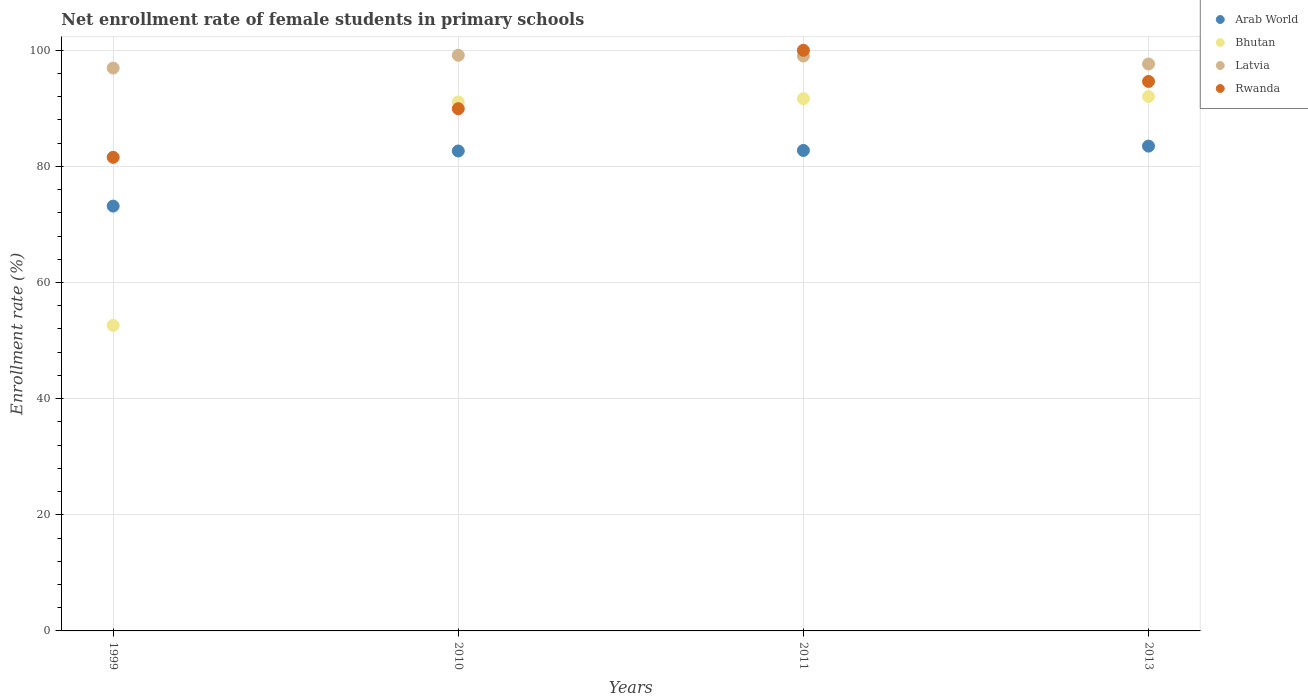What is the net enrollment rate of female students in primary schools in Latvia in 1999?
Your answer should be compact. 96.93. Across all years, what is the maximum net enrollment rate of female students in primary schools in Arab World?
Provide a succinct answer. 83.49. Across all years, what is the minimum net enrollment rate of female students in primary schools in Bhutan?
Provide a succinct answer. 52.61. In which year was the net enrollment rate of female students in primary schools in Latvia maximum?
Your answer should be very brief. 2010. In which year was the net enrollment rate of female students in primary schools in Arab World minimum?
Your response must be concise. 1999. What is the total net enrollment rate of female students in primary schools in Bhutan in the graph?
Offer a terse response. 327.39. What is the difference between the net enrollment rate of female students in primary schools in Bhutan in 1999 and that in 2011?
Give a very brief answer. -39.05. What is the difference between the net enrollment rate of female students in primary schools in Rwanda in 2013 and the net enrollment rate of female students in primary schools in Bhutan in 1999?
Offer a very short reply. 42.01. What is the average net enrollment rate of female students in primary schools in Latvia per year?
Your answer should be very brief. 98.17. In the year 2013, what is the difference between the net enrollment rate of female students in primary schools in Bhutan and net enrollment rate of female students in primary schools in Latvia?
Provide a succinct answer. -5.59. In how many years, is the net enrollment rate of female students in primary schools in Arab World greater than 72 %?
Make the answer very short. 4. What is the ratio of the net enrollment rate of female students in primary schools in Latvia in 2011 to that in 2013?
Provide a short and direct response. 1.01. Is the difference between the net enrollment rate of female students in primary schools in Bhutan in 2010 and 2013 greater than the difference between the net enrollment rate of female students in primary schools in Latvia in 2010 and 2013?
Your answer should be very brief. No. What is the difference between the highest and the second highest net enrollment rate of female students in primary schools in Latvia?
Keep it short and to the point. 0.13. What is the difference between the highest and the lowest net enrollment rate of female students in primary schools in Bhutan?
Your response must be concise. 39.42. Is the sum of the net enrollment rate of female students in primary schools in Arab World in 2010 and 2013 greater than the maximum net enrollment rate of female students in primary schools in Bhutan across all years?
Give a very brief answer. Yes. Is it the case that in every year, the sum of the net enrollment rate of female students in primary schools in Bhutan and net enrollment rate of female students in primary schools in Arab World  is greater than the sum of net enrollment rate of female students in primary schools in Rwanda and net enrollment rate of female students in primary schools in Latvia?
Offer a terse response. No. Does the net enrollment rate of female students in primary schools in Rwanda monotonically increase over the years?
Ensure brevity in your answer.  No. Is the net enrollment rate of female students in primary schools in Latvia strictly greater than the net enrollment rate of female students in primary schools in Bhutan over the years?
Your answer should be very brief. Yes. How many years are there in the graph?
Keep it short and to the point. 4. Are the values on the major ticks of Y-axis written in scientific E-notation?
Keep it short and to the point. No. Does the graph contain grids?
Give a very brief answer. Yes. Where does the legend appear in the graph?
Offer a terse response. Top right. How many legend labels are there?
Provide a short and direct response. 4. What is the title of the graph?
Offer a very short reply. Net enrollment rate of female students in primary schools. Does "Chile" appear as one of the legend labels in the graph?
Provide a short and direct response. No. What is the label or title of the X-axis?
Your answer should be very brief. Years. What is the label or title of the Y-axis?
Offer a terse response. Enrollment rate (%). What is the Enrollment rate (%) in Arab World in 1999?
Provide a succinct answer. 73.16. What is the Enrollment rate (%) of Bhutan in 1999?
Make the answer very short. 52.61. What is the Enrollment rate (%) in Latvia in 1999?
Offer a very short reply. 96.93. What is the Enrollment rate (%) in Rwanda in 1999?
Provide a short and direct response. 81.56. What is the Enrollment rate (%) in Arab World in 2010?
Give a very brief answer. 82.65. What is the Enrollment rate (%) in Bhutan in 2010?
Keep it short and to the point. 91.09. What is the Enrollment rate (%) in Latvia in 2010?
Give a very brief answer. 99.13. What is the Enrollment rate (%) in Rwanda in 2010?
Ensure brevity in your answer.  89.93. What is the Enrollment rate (%) in Arab World in 2011?
Give a very brief answer. 82.74. What is the Enrollment rate (%) of Bhutan in 2011?
Give a very brief answer. 91.66. What is the Enrollment rate (%) in Latvia in 2011?
Your response must be concise. 99. What is the Enrollment rate (%) in Rwanda in 2011?
Give a very brief answer. 99.98. What is the Enrollment rate (%) in Arab World in 2013?
Your answer should be compact. 83.49. What is the Enrollment rate (%) of Bhutan in 2013?
Provide a short and direct response. 92.03. What is the Enrollment rate (%) of Latvia in 2013?
Provide a short and direct response. 97.63. What is the Enrollment rate (%) in Rwanda in 2013?
Your response must be concise. 94.62. Across all years, what is the maximum Enrollment rate (%) of Arab World?
Ensure brevity in your answer.  83.49. Across all years, what is the maximum Enrollment rate (%) of Bhutan?
Provide a short and direct response. 92.03. Across all years, what is the maximum Enrollment rate (%) in Latvia?
Your answer should be very brief. 99.13. Across all years, what is the maximum Enrollment rate (%) in Rwanda?
Provide a succinct answer. 99.98. Across all years, what is the minimum Enrollment rate (%) of Arab World?
Keep it short and to the point. 73.16. Across all years, what is the minimum Enrollment rate (%) in Bhutan?
Make the answer very short. 52.61. Across all years, what is the minimum Enrollment rate (%) of Latvia?
Make the answer very short. 96.93. Across all years, what is the minimum Enrollment rate (%) in Rwanda?
Your answer should be compact. 81.56. What is the total Enrollment rate (%) in Arab World in the graph?
Offer a terse response. 322.03. What is the total Enrollment rate (%) in Bhutan in the graph?
Ensure brevity in your answer.  327.39. What is the total Enrollment rate (%) in Latvia in the graph?
Provide a short and direct response. 392.68. What is the total Enrollment rate (%) of Rwanda in the graph?
Keep it short and to the point. 366.09. What is the difference between the Enrollment rate (%) of Arab World in 1999 and that in 2010?
Your answer should be very brief. -9.49. What is the difference between the Enrollment rate (%) in Bhutan in 1999 and that in 2010?
Give a very brief answer. -38.47. What is the difference between the Enrollment rate (%) in Latvia in 1999 and that in 2010?
Make the answer very short. -2.2. What is the difference between the Enrollment rate (%) in Rwanda in 1999 and that in 2010?
Your answer should be compact. -8.37. What is the difference between the Enrollment rate (%) in Arab World in 1999 and that in 2011?
Offer a terse response. -9.58. What is the difference between the Enrollment rate (%) in Bhutan in 1999 and that in 2011?
Keep it short and to the point. -39.05. What is the difference between the Enrollment rate (%) of Latvia in 1999 and that in 2011?
Ensure brevity in your answer.  -2.07. What is the difference between the Enrollment rate (%) of Rwanda in 1999 and that in 2011?
Your answer should be very brief. -18.42. What is the difference between the Enrollment rate (%) in Arab World in 1999 and that in 2013?
Provide a short and direct response. -10.33. What is the difference between the Enrollment rate (%) in Bhutan in 1999 and that in 2013?
Keep it short and to the point. -39.42. What is the difference between the Enrollment rate (%) in Latvia in 1999 and that in 2013?
Keep it short and to the point. -0.7. What is the difference between the Enrollment rate (%) of Rwanda in 1999 and that in 2013?
Offer a very short reply. -13.07. What is the difference between the Enrollment rate (%) in Arab World in 2010 and that in 2011?
Make the answer very short. -0.09. What is the difference between the Enrollment rate (%) in Bhutan in 2010 and that in 2011?
Provide a short and direct response. -0.58. What is the difference between the Enrollment rate (%) in Latvia in 2010 and that in 2011?
Keep it short and to the point. 0.13. What is the difference between the Enrollment rate (%) of Rwanda in 2010 and that in 2011?
Ensure brevity in your answer.  -10.05. What is the difference between the Enrollment rate (%) of Arab World in 2010 and that in 2013?
Provide a short and direct response. -0.84. What is the difference between the Enrollment rate (%) of Bhutan in 2010 and that in 2013?
Give a very brief answer. -0.95. What is the difference between the Enrollment rate (%) in Latvia in 2010 and that in 2013?
Keep it short and to the point. 1.5. What is the difference between the Enrollment rate (%) in Rwanda in 2010 and that in 2013?
Give a very brief answer. -4.69. What is the difference between the Enrollment rate (%) in Arab World in 2011 and that in 2013?
Your answer should be very brief. -0.75. What is the difference between the Enrollment rate (%) in Bhutan in 2011 and that in 2013?
Offer a terse response. -0.37. What is the difference between the Enrollment rate (%) of Latvia in 2011 and that in 2013?
Provide a short and direct response. 1.37. What is the difference between the Enrollment rate (%) of Rwanda in 2011 and that in 2013?
Keep it short and to the point. 5.36. What is the difference between the Enrollment rate (%) in Arab World in 1999 and the Enrollment rate (%) in Bhutan in 2010?
Give a very brief answer. -17.93. What is the difference between the Enrollment rate (%) of Arab World in 1999 and the Enrollment rate (%) of Latvia in 2010?
Offer a very short reply. -25.97. What is the difference between the Enrollment rate (%) in Arab World in 1999 and the Enrollment rate (%) in Rwanda in 2010?
Your response must be concise. -16.77. What is the difference between the Enrollment rate (%) in Bhutan in 1999 and the Enrollment rate (%) in Latvia in 2010?
Offer a very short reply. -46.51. What is the difference between the Enrollment rate (%) of Bhutan in 1999 and the Enrollment rate (%) of Rwanda in 2010?
Ensure brevity in your answer.  -37.32. What is the difference between the Enrollment rate (%) in Latvia in 1999 and the Enrollment rate (%) in Rwanda in 2010?
Your response must be concise. 7. What is the difference between the Enrollment rate (%) in Arab World in 1999 and the Enrollment rate (%) in Bhutan in 2011?
Offer a very short reply. -18.5. What is the difference between the Enrollment rate (%) of Arab World in 1999 and the Enrollment rate (%) of Latvia in 2011?
Your answer should be compact. -25.84. What is the difference between the Enrollment rate (%) of Arab World in 1999 and the Enrollment rate (%) of Rwanda in 2011?
Provide a short and direct response. -26.82. What is the difference between the Enrollment rate (%) of Bhutan in 1999 and the Enrollment rate (%) of Latvia in 2011?
Ensure brevity in your answer.  -46.38. What is the difference between the Enrollment rate (%) in Bhutan in 1999 and the Enrollment rate (%) in Rwanda in 2011?
Keep it short and to the point. -47.37. What is the difference between the Enrollment rate (%) in Latvia in 1999 and the Enrollment rate (%) in Rwanda in 2011?
Your answer should be very brief. -3.05. What is the difference between the Enrollment rate (%) of Arab World in 1999 and the Enrollment rate (%) of Bhutan in 2013?
Your response must be concise. -18.87. What is the difference between the Enrollment rate (%) of Arab World in 1999 and the Enrollment rate (%) of Latvia in 2013?
Your answer should be very brief. -24.47. What is the difference between the Enrollment rate (%) in Arab World in 1999 and the Enrollment rate (%) in Rwanda in 2013?
Ensure brevity in your answer.  -21.47. What is the difference between the Enrollment rate (%) of Bhutan in 1999 and the Enrollment rate (%) of Latvia in 2013?
Provide a succinct answer. -45.01. What is the difference between the Enrollment rate (%) of Bhutan in 1999 and the Enrollment rate (%) of Rwanda in 2013?
Offer a terse response. -42.01. What is the difference between the Enrollment rate (%) in Latvia in 1999 and the Enrollment rate (%) in Rwanda in 2013?
Your answer should be compact. 2.31. What is the difference between the Enrollment rate (%) of Arab World in 2010 and the Enrollment rate (%) of Bhutan in 2011?
Ensure brevity in your answer.  -9.02. What is the difference between the Enrollment rate (%) in Arab World in 2010 and the Enrollment rate (%) in Latvia in 2011?
Your response must be concise. -16.35. What is the difference between the Enrollment rate (%) in Arab World in 2010 and the Enrollment rate (%) in Rwanda in 2011?
Offer a very short reply. -17.33. What is the difference between the Enrollment rate (%) in Bhutan in 2010 and the Enrollment rate (%) in Latvia in 2011?
Your answer should be very brief. -7.91. What is the difference between the Enrollment rate (%) of Bhutan in 2010 and the Enrollment rate (%) of Rwanda in 2011?
Your answer should be compact. -8.89. What is the difference between the Enrollment rate (%) in Latvia in 2010 and the Enrollment rate (%) in Rwanda in 2011?
Offer a very short reply. -0.85. What is the difference between the Enrollment rate (%) in Arab World in 2010 and the Enrollment rate (%) in Bhutan in 2013?
Provide a short and direct response. -9.39. What is the difference between the Enrollment rate (%) in Arab World in 2010 and the Enrollment rate (%) in Latvia in 2013?
Your answer should be very brief. -14.98. What is the difference between the Enrollment rate (%) in Arab World in 2010 and the Enrollment rate (%) in Rwanda in 2013?
Your response must be concise. -11.98. What is the difference between the Enrollment rate (%) of Bhutan in 2010 and the Enrollment rate (%) of Latvia in 2013?
Keep it short and to the point. -6.54. What is the difference between the Enrollment rate (%) of Bhutan in 2010 and the Enrollment rate (%) of Rwanda in 2013?
Make the answer very short. -3.54. What is the difference between the Enrollment rate (%) in Latvia in 2010 and the Enrollment rate (%) in Rwanda in 2013?
Give a very brief answer. 4.5. What is the difference between the Enrollment rate (%) of Arab World in 2011 and the Enrollment rate (%) of Bhutan in 2013?
Your response must be concise. -9.29. What is the difference between the Enrollment rate (%) in Arab World in 2011 and the Enrollment rate (%) in Latvia in 2013?
Provide a short and direct response. -14.89. What is the difference between the Enrollment rate (%) in Arab World in 2011 and the Enrollment rate (%) in Rwanda in 2013?
Provide a succinct answer. -11.88. What is the difference between the Enrollment rate (%) of Bhutan in 2011 and the Enrollment rate (%) of Latvia in 2013?
Offer a very short reply. -5.96. What is the difference between the Enrollment rate (%) in Bhutan in 2011 and the Enrollment rate (%) in Rwanda in 2013?
Your answer should be very brief. -2.96. What is the difference between the Enrollment rate (%) of Latvia in 2011 and the Enrollment rate (%) of Rwanda in 2013?
Make the answer very short. 4.37. What is the average Enrollment rate (%) of Arab World per year?
Ensure brevity in your answer.  80.51. What is the average Enrollment rate (%) of Bhutan per year?
Give a very brief answer. 81.85. What is the average Enrollment rate (%) in Latvia per year?
Your answer should be compact. 98.17. What is the average Enrollment rate (%) of Rwanda per year?
Provide a succinct answer. 91.52. In the year 1999, what is the difference between the Enrollment rate (%) of Arab World and Enrollment rate (%) of Bhutan?
Provide a succinct answer. 20.54. In the year 1999, what is the difference between the Enrollment rate (%) of Arab World and Enrollment rate (%) of Latvia?
Provide a short and direct response. -23.77. In the year 1999, what is the difference between the Enrollment rate (%) in Arab World and Enrollment rate (%) in Rwanda?
Give a very brief answer. -8.4. In the year 1999, what is the difference between the Enrollment rate (%) in Bhutan and Enrollment rate (%) in Latvia?
Your answer should be compact. -44.32. In the year 1999, what is the difference between the Enrollment rate (%) in Bhutan and Enrollment rate (%) in Rwanda?
Keep it short and to the point. -28.94. In the year 1999, what is the difference between the Enrollment rate (%) of Latvia and Enrollment rate (%) of Rwanda?
Your answer should be very brief. 15.37. In the year 2010, what is the difference between the Enrollment rate (%) in Arab World and Enrollment rate (%) in Bhutan?
Provide a short and direct response. -8.44. In the year 2010, what is the difference between the Enrollment rate (%) of Arab World and Enrollment rate (%) of Latvia?
Keep it short and to the point. -16.48. In the year 2010, what is the difference between the Enrollment rate (%) in Arab World and Enrollment rate (%) in Rwanda?
Offer a very short reply. -7.28. In the year 2010, what is the difference between the Enrollment rate (%) in Bhutan and Enrollment rate (%) in Latvia?
Ensure brevity in your answer.  -8.04. In the year 2010, what is the difference between the Enrollment rate (%) in Bhutan and Enrollment rate (%) in Rwanda?
Provide a succinct answer. 1.16. In the year 2010, what is the difference between the Enrollment rate (%) of Latvia and Enrollment rate (%) of Rwanda?
Your answer should be very brief. 9.2. In the year 2011, what is the difference between the Enrollment rate (%) of Arab World and Enrollment rate (%) of Bhutan?
Offer a very short reply. -8.92. In the year 2011, what is the difference between the Enrollment rate (%) in Arab World and Enrollment rate (%) in Latvia?
Offer a very short reply. -16.26. In the year 2011, what is the difference between the Enrollment rate (%) in Arab World and Enrollment rate (%) in Rwanda?
Your answer should be very brief. -17.24. In the year 2011, what is the difference between the Enrollment rate (%) of Bhutan and Enrollment rate (%) of Latvia?
Offer a terse response. -7.33. In the year 2011, what is the difference between the Enrollment rate (%) of Bhutan and Enrollment rate (%) of Rwanda?
Offer a terse response. -8.32. In the year 2011, what is the difference between the Enrollment rate (%) in Latvia and Enrollment rate (%) in Rwanda?
Give a very brief answer. -0.98. In the year 2013, what is the difference between the Enrollment rate (%) of Arab World and Enrollment rate (%) of Bhutan?
Offer a terse response. -8.54. In the year 2013, what is the difference between the Enrollment rate (%) of Arab World and Enrollment rate (%) of Latvia?
Keep it short and to the point. -14.14. In the year 2013, what is the difference between the Enrollment rate (%) of Arab World and Enrollment rate (%) of Rwanda?
Offer a very short reply. -11.14. In the year 2013, what is the difference between the Enrollment rate (%) in Bhutan and Enrollment rate (%) in Latvia?
Offer a very short reply. -5.59. In the year 2013, what is the difference between the Enrollment rate (%) in Bhutan and Enrollment rate (%) in Rwanda?
Your answer should be compact. -2.59. In the year 2013, what is the difference between the Enrollment rate (%) in Latvia and Enrollment rate (%) in Rwanda?
Make the answer very short. 3. What is the ratio of the Enrollment rate (%) in Arab World in 1999 to that in 2010?
Offer a very short reply. 0.89. What is the ratio of the Enrollment rate (%) of Bhutan in 1999 to that in 2010?
Offer a terse response. 0.58. What is the ratio of the Enrollment rate (%) in Latvia in 1999 to that in 2010?
Your response must be concise. 0.98. What is the ratio of the Enrollment rate (%) in Rwanda in 1999 to that in 2010?
Give a very brief answer. 0.91. What is the ratio of the Enrollment rate (%) of Arab World in 1999 to that in 2011?
Offer a terse response. 0.88. What is the ratio of the Enrollment rate (%) in Bhutan in 1999 to that in 2011?
Ensure brevity in your answer.  0.57. What is the ratio of the Enrollment rate (%) in Latvia in 1999 to that in 2011?
Offer a very short reply. 0.98. What is the ratio of the Enrollment rate (%) of Rwanda in 1999 to that in 2011?
Your response must be concise. 0.82. What is the ratio of the Enrollment rate (%) in Arab World in 1999 to that in 2013?
Provide a short and direct response. 0.88. What is the ratio of the Enrollment rate (%) in Bhutan in 1999 to that in 2013?
Ensure brevity in your answer.  0.57. What is the ratio of the Enrollment rate (%) of Rwanda in 1999 to that in 2013?
Offer a very short reply. 0.86. What is the ratio of the Enrollment rate (%) of Arab World in 2010 to that in 2011?
Ensure brevity in your answer.  1. What is the ratio of the Enrollment rate (%) in Bhutan in 2010 to that in 2011?
Your answer should be very brief. 0.99. What is the ratio of the Enrollment rate (%) in Latvia in 2010 to that in 2011?
Your answer should be very brief. 1. What is the ratio of the Enrollment rate (%) of Rwanda in 2010 to that in 2011?
Provide a succinct answer. 0.9. What is the ratio of the Enrollment rate (%) in Arab World in 2010 to that in 2013?
Give a very brief answer. 0.99. What is the ratio of the Enrollment rate (%) of Bhutan in 2010 to that in 2013?
Provide a short and direct response. 0.99. What is the ratio of the Enrollment rate (%) of Latvia in 2010 to that in 2013?
Keep it short and to the point. 1.02. What is the ratio of the Enrollment rate (%) of Rwanda in 2010 to that in 2013?
Offer a very short reply. 0.95. What is the ratio of the Enrollment rate (%) in Latvia in 2011 to that in 2013?
Provide a short and direct response. 1.01. What is the ratio of the Enrollment rate (%) in Rwanda in 2011 to that in 2013?
Provide a short and direct response. 1.06. What is the difference between the highest and the second highest Enrollment rate (%) in Arab World?
Your response must be concise. 0.75. What is the difference between the highest and the second highest Enrollment rate (%) in Bhutan?
Your answer should be very brief. 0.37. What is the difference between the highest and the second highest Enrollment rate (%) in Latvia?
Provide a succinct answer. 0.13. What is the difference between the highest and the second highest Enrollment rate (%) of Rwanda?
Make the answer very short. 5.36. What is the difference between the highest and the lowest Enrollment rate (%) of Arab World?
Give a very brief answer. 10.33. What is the difference between the highest and the lowest Enrollment rate (%) in Bhutan?
Your response must be concise. 39.42. What is the difference between the highest and the lowest Enrollment rate (%) of Latvia?
Offer a terse response. 2.2. What is the difference between the highest and the lowest Enrollment rate (%) of Rwanda?
Keep it short and to the point. 18.42. 